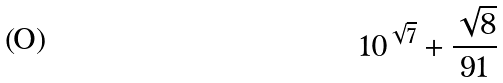<formula> <loc_0><loc_0><loc_500><loc_500>1 0 ^ { \sqrt { 7 } } + \frac { \sqrt { 8 } } { 9 1 }</formula> 